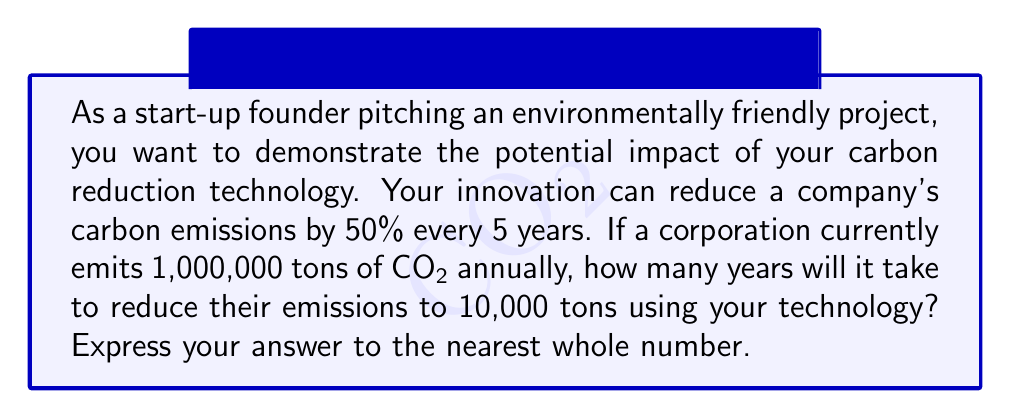What is the answer to this math problem? Let's approach this step-by-step using logarithms:

1) First, we need to set up our equation. Let $y$ be the number of years and $x$ be the number of 5-year periods.

   $y = 5x$

2) We know that every 5 years, the emissions are reduced by 50%. This means that after $x$ periods of 5 years, the emissions will be:

   $1,000,000 * (0.5)^x = 10,000$

3) Now, let's solve this equation using logarithms. First, divide both sides by 1,000,000:

   $(0.5)^x = 0.01$

4) Take the logarithm (base 10) of both sides:

   $\log(0.5)^x = \log(0.01)$

5) Use the logarithm property $\log(a^n) = n\log(a)$:

   $x\log(0.5) = \log(0.01)$

6) Solve for $x$:

   $x = \frac{\log(0.01)}{\log(0.5)}$

7) Calculate this value:

   $x = \frac{-2}{-0.30103} \approx 6.643856$

8) Remember that $x$ is the number of 5-year periods. To get the number of years, multiply by 5:

   $y = 5x \approx 5 * 6.643856 = 33.21928$

9) Rounding to the nearest whole number:

   $y \approx 33$ years
Answer: 33 years 